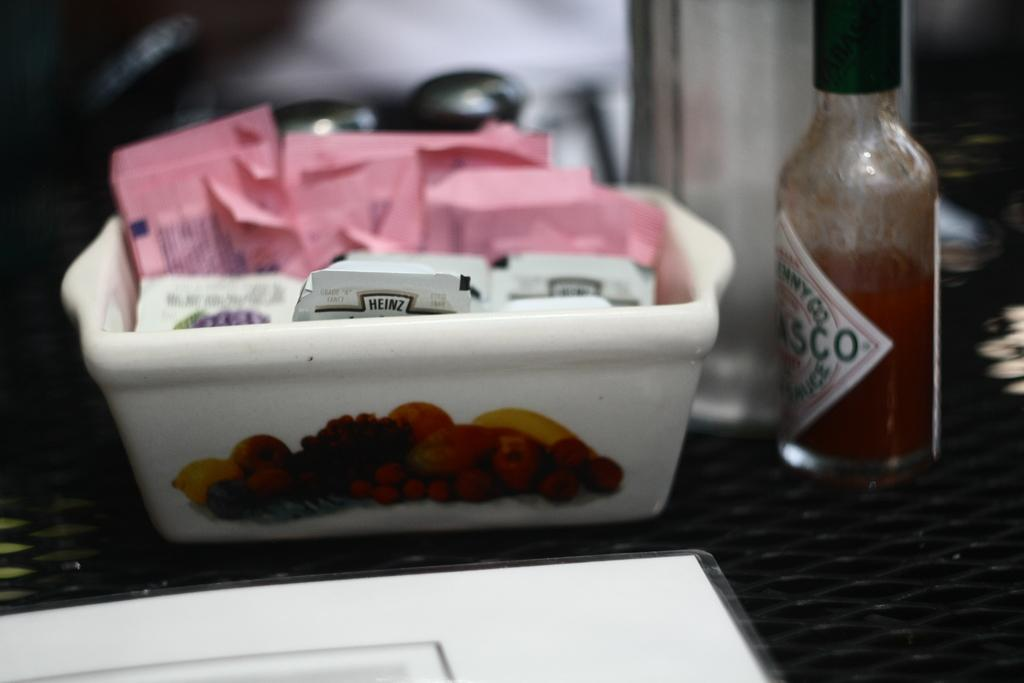<image>
Provide a brief description of the given image. Bottle of Tobasco on top of a table next to some sugar. 